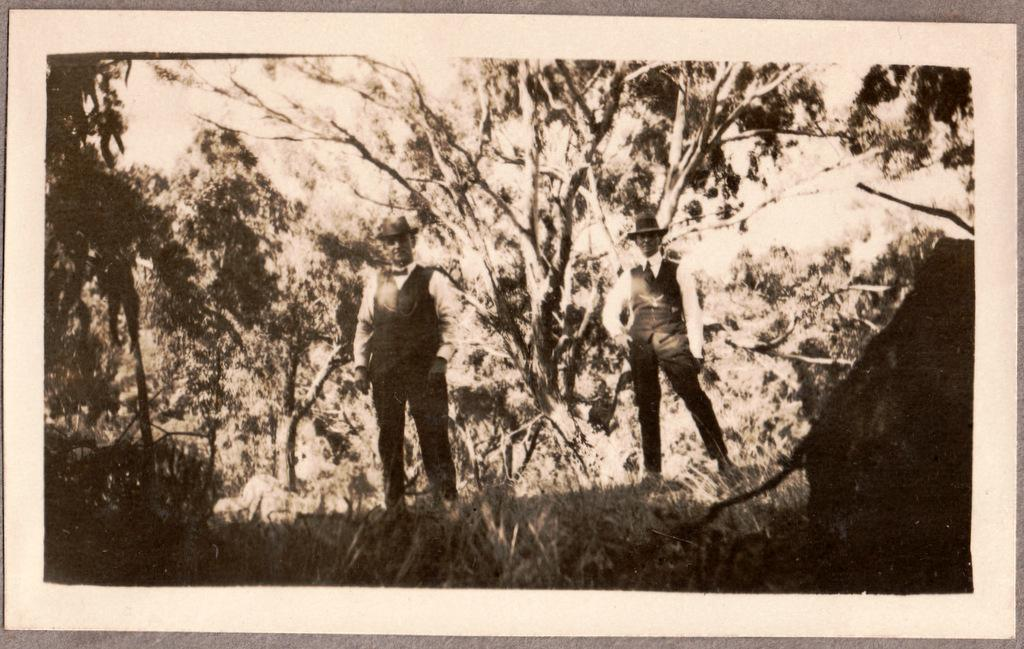What type of vegetation is present in the image? There are trees and grass in the image. How many people are in the image? There are two people in the image. What are the people wearing on their heads? The two people are wearing black color hats. What type of clothing are the people wearing on their upper bodies? The two people are wearing black color jackets. Can you tell me which part of the church is visible in the image? There is no church present in the image. How many flies can be seen in the image? There are no flies visible in the image. 